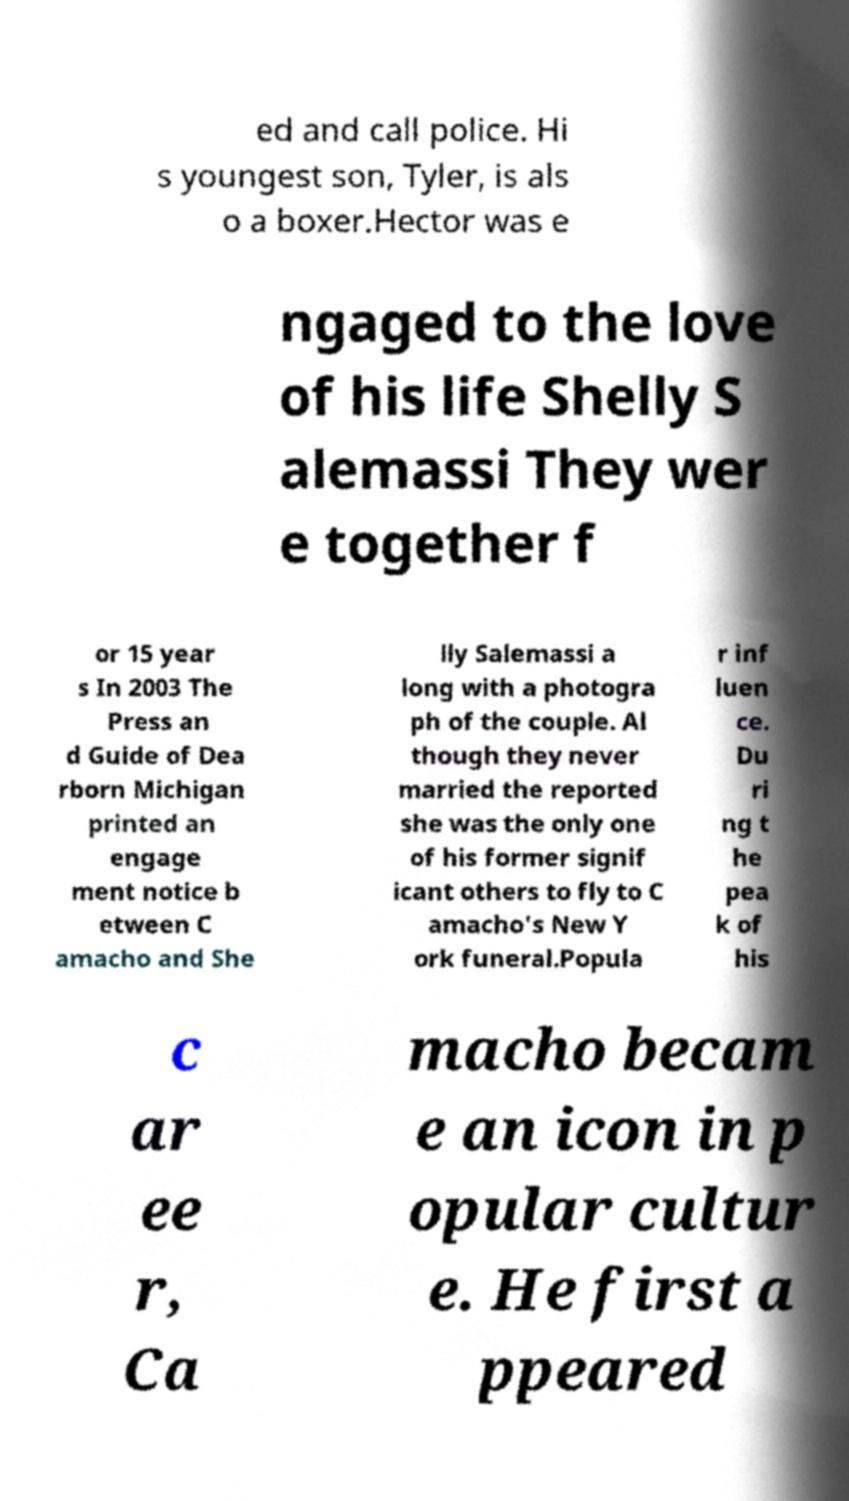Please identify and transcribe the text found in this image. ed and call police. Hi s youngest son, Tyler, is als o a boxer.Hector was e ngaged to the love of his life Shelly S alemassi They wer e together f or 15 year s In 2003 The Press an d Guide of Dea rborn Michigan printed an engage ment notice b etween C amacho and She lly Salemassi a long with a photogra ph of the couple. Al though they never married the reported she was the only one of his former signif icant others to fly to C amacho's New Y ork funeral.Popula r inf luen ce. Du ri ng t he pea k of his c ar ee r, Ca macho becam e an icon in p opular cultur e. He first a ppeared 